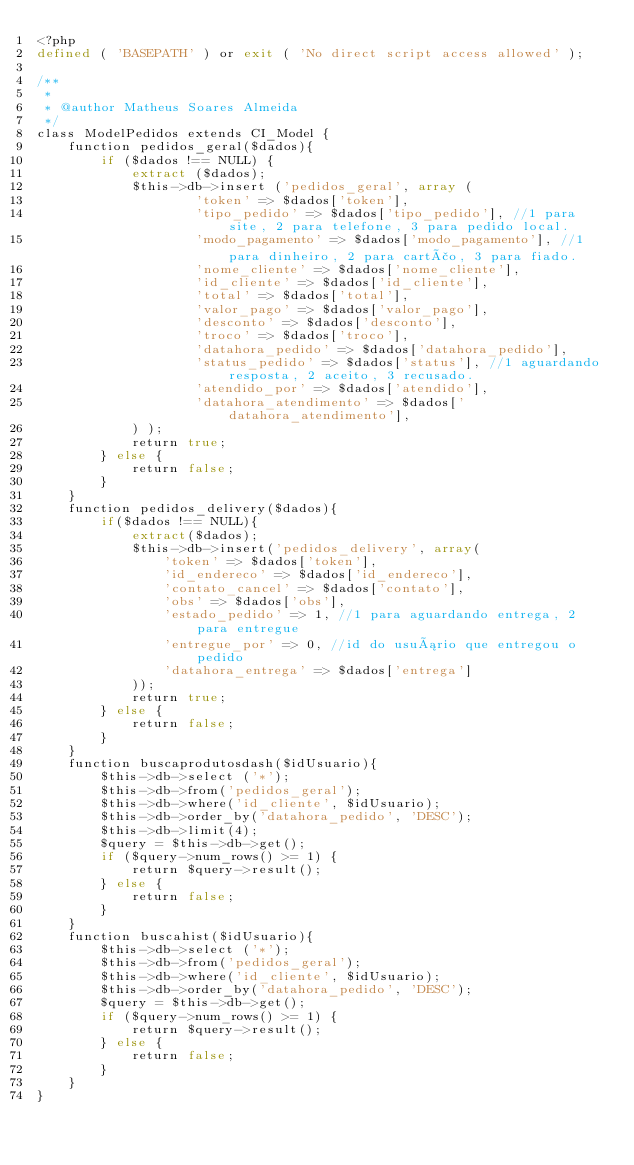<code> <loc_0><loc_0><loc_500><loc_500><_PHP_><?php
defined ( 'BASEPATH' ) or exit ( 'No direct script access allowed' );

/**
 *
 * @author Matheus Soares Almeida
 */
class ModelPedidos extends CI_Model {
	function pedidos_geral($dados){
		if ($dados !== NULL) {
			extract ($dados);
			$this->db->insert ('pedidos_geral', array (
					'token' => $dados['token'],
					'tipo_pedido' => $dados['tipo_pedido'], //1 para site, 2 para telefone, 3 para pedido local.
					'modo_pagamento' => $dados['modo_pagamento'], //1 para dinheiro, 2 para cartão, 3 para fiado.
					'nome_cliente' => $dados['nome_cliente'],
					'id_cliente' => $dados['id_cliente'],
					'total' => $dados['total'],
					'valor_pago' => $dados['valor_pago'],
					'desconto' => $dados['desconto'],
					'troco' => $dados['troco'],
					'datahora_pedido' => $dados['datahora_pedido'],
					'status_pedido' => $dados['status'], //1 aguardando resposta, 2 aceito, 3 recusado.
					'atendido_por' => $dados['atendido'],
					'datahora_atendimento' => $dados['datahora_atendimento'],					
			) );
			return true;
		} else {
			return false;
		}
	}
	function pedidos_delivery($dados){
		if($dados !== NULL){
			extract($dados);
			$this->db->insert('pedidos_delivery', array(
				'token' => $dados['token'],
				'id_endereco' => $dados['id_endereco'],
				'contato_cancel' => $dados['contato'],
				'obs' => $dados['obs'],
				'estado_pedido' => 1, //1 para aguardando entrega, 2 para entregue
				'entregue_por' => 0, //id do usuário que entregou o pedido
				'datahora_entrega' => $dados['entrega']
			));
			return true;
		} else {
			return false;
		}
	}
	function buscaprodutosdash($idUsuario){
		$this->db->select ('*');
		$this->db->from('pedidos_geral');
		$this->db->where('id_cliente', $idUsuario);
		$this->db->order_by('datahora_pedido', 'DESC');
		$this->db->limit(4);	
		$query = $this->db->get();
		if ($query->num_rows() >= 1) {
			return $query->result();
		} else {
			return false;
		}
	}
	function buscahist($idUsuario){
		$this->db->select ('*');
		$this->db->from('pedidos_geral');
		$this->db->where('id_cliente', $idUsuario);
		$this->db->order_by('datahora_pedido', 'DESC');
		$query = $this->db->get();
		if ($query->num_rows() >= 1) {
			return $query->result();
		} else {
			return false;
		}
	}
}</code> 